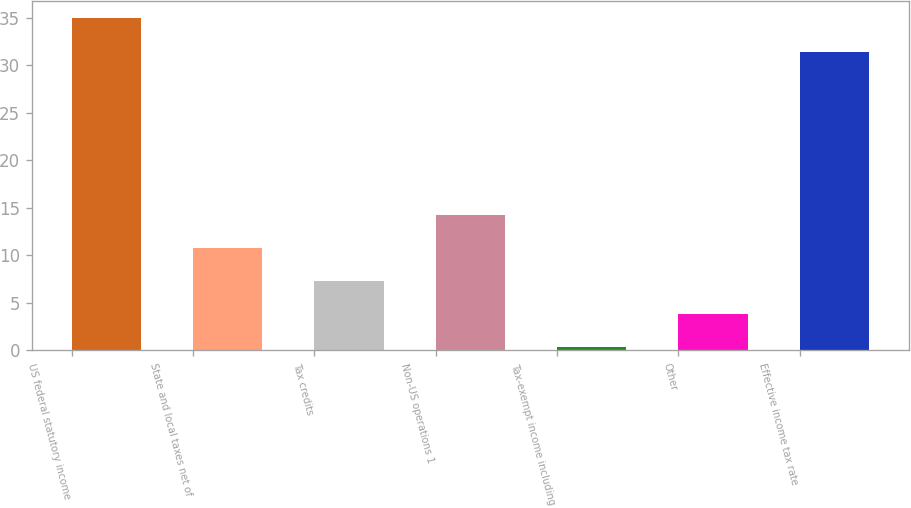Convert chart to OTSL. <chart><loc_0><loc_0><loc_500><loc_500><bar_chart><fcel>US federal statutory income<fcel>State and local taxes net of<fcel>Tax credits<fcel>Non-US operations 1<fcel>Tax-exempt income including<fcel>Other<fcel>Effective income tax rate<nl><fcel>35<fcel>10.71<fcel>7.24<fcel>14.18<fcel>0.3<fcel>3.77<fcel>31.4<nl></chart> 